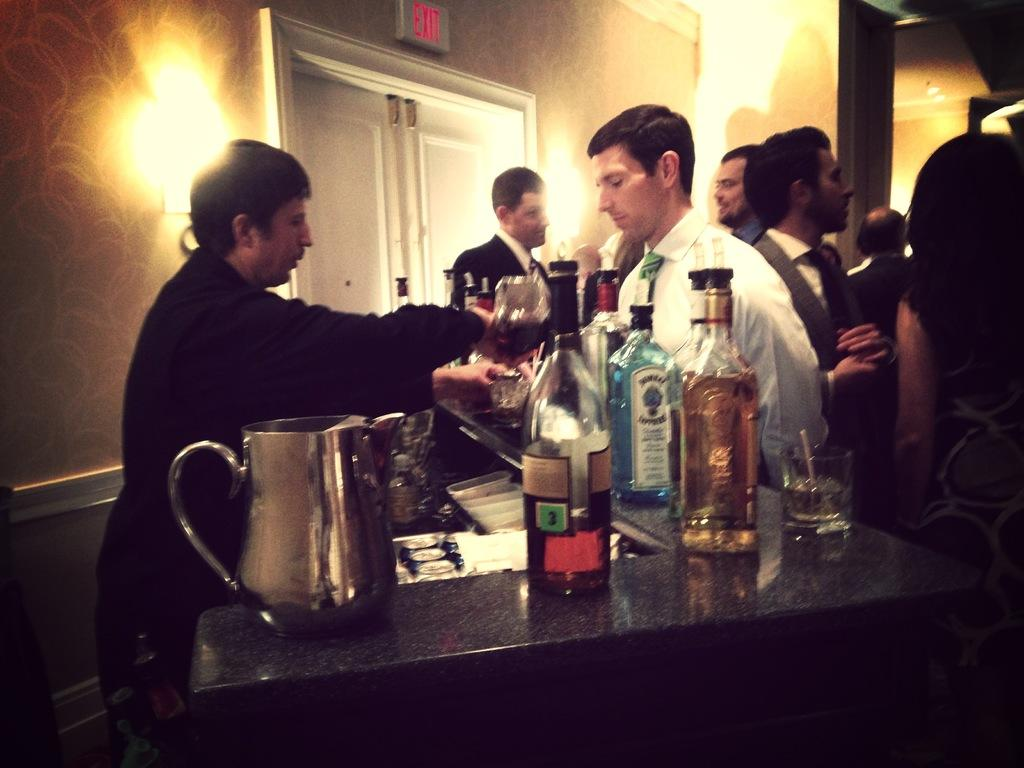<image>
Provide a brief description of the given image. A bartender is standing behind a bar with a bottle of Bombay Sapphire in front of him. 